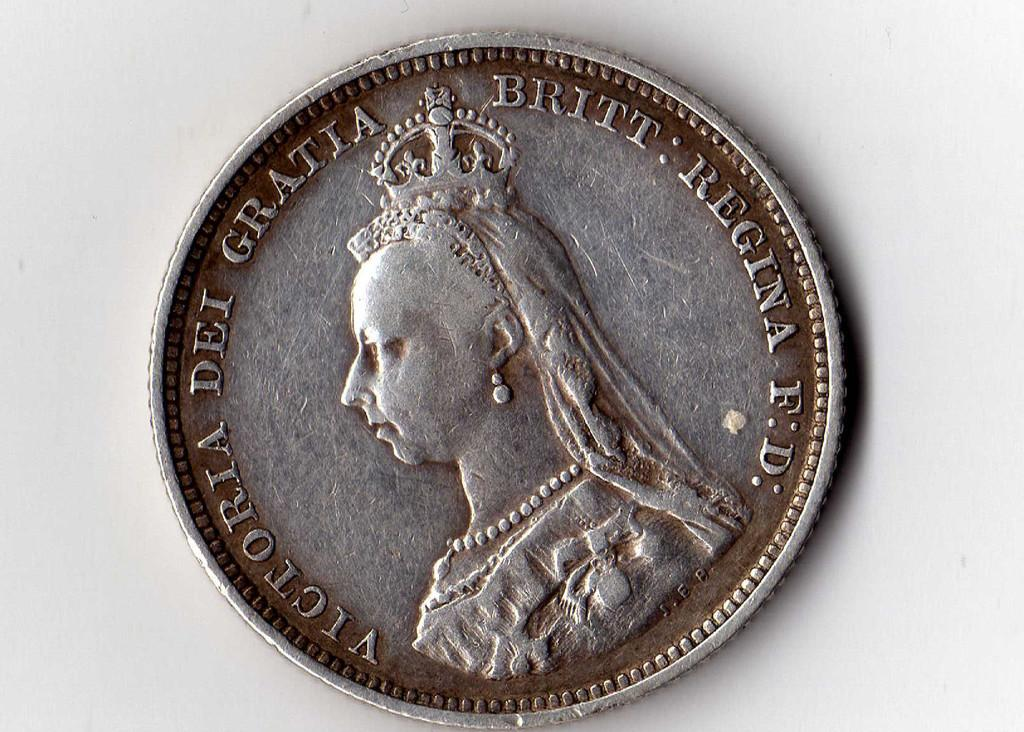<image>
Summarize the visual content of the image. A coin that reads Victoria Dei gratta britt regina F. D 